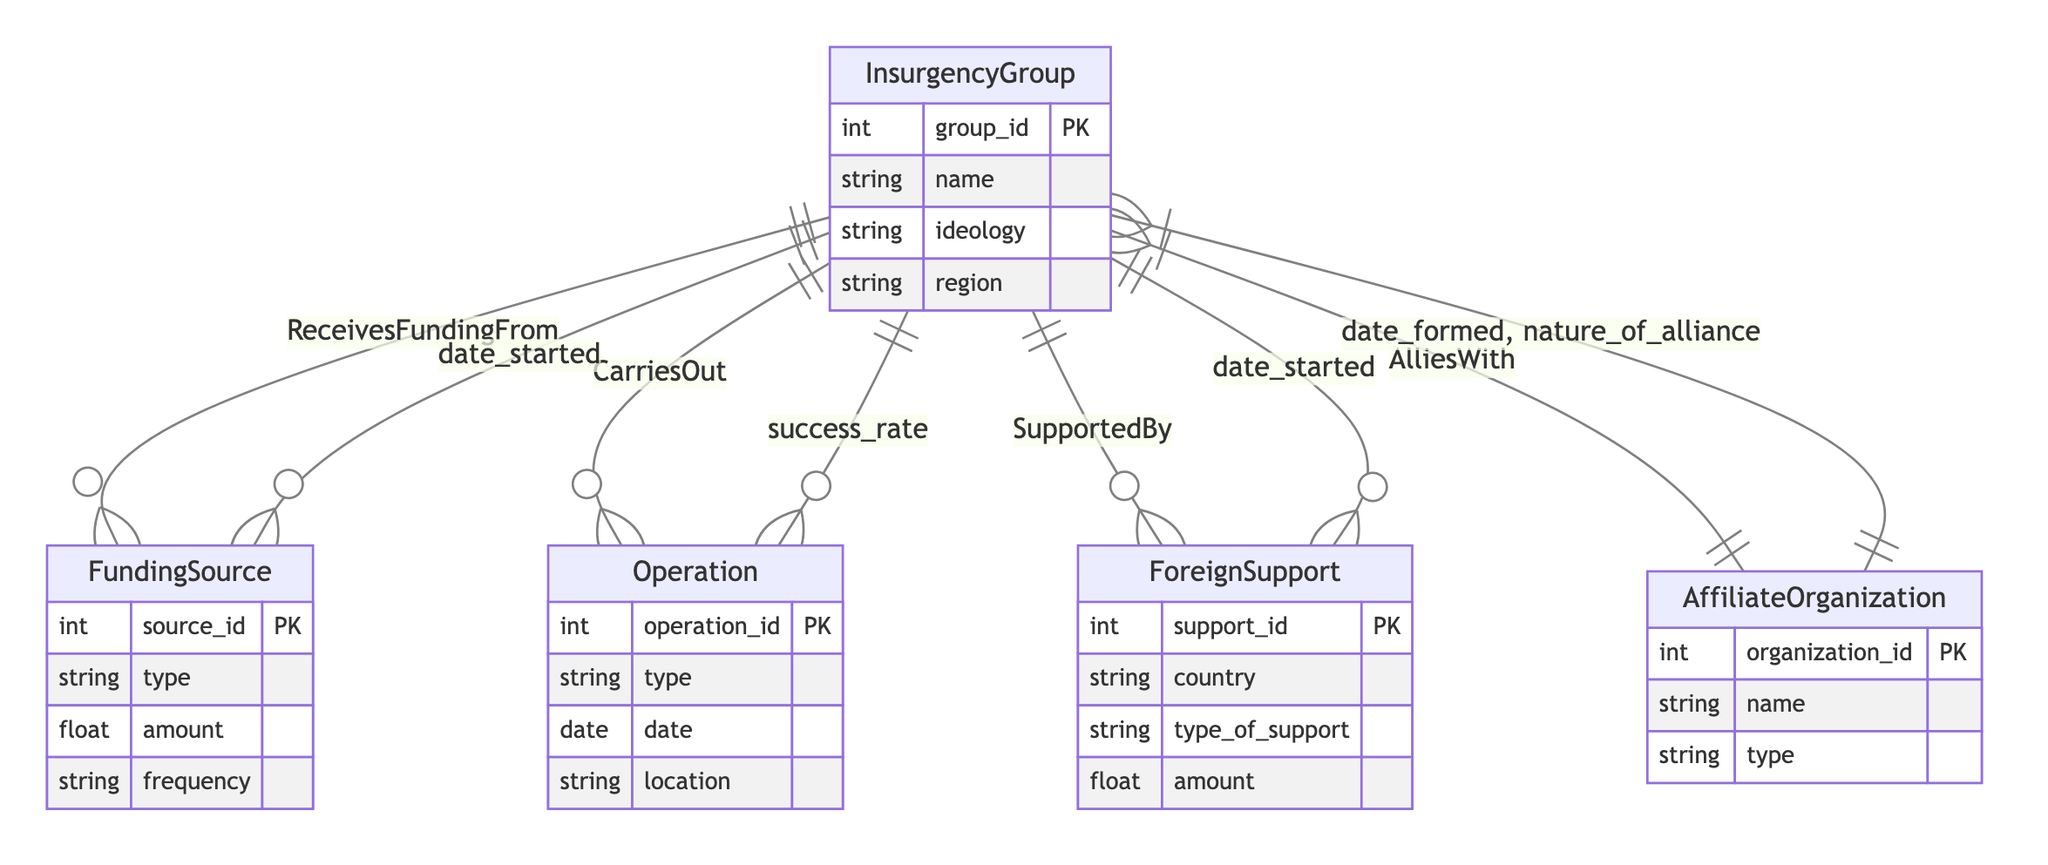What are the primary entities represented in the diagram? The entities in the diagram include InsurgencyGroup, FundingSource, Operation, ForeignSupport, and AffiliateOrganization. Each entity represents a distinct aspect of insurgency movements and their dynamics.
Answer: InsurgencyGroup, FundingSource, Operation, ForeignSupport, AffiliateOrganization How many relationships exist between the InsurgencyGroup and FundingSource? The diagram shows one relationship called "ReceivesFundingFrom" between InsurgencyGroup and FundingSource, which indicates that an insurgency group receives funding from one or more funding sources.
Answer: One What type of support can an InsurgencyGroup receive from ForeignSupport? The InsurgencyGroup can receive various types of support, including arms, training, and financial assistance, as specified in the attributes of the ForeignSupport entity.
Answer: Arms, training, financial What is the nature of the relationship between InsurgencyGroup and AffiliateOrganization? The relationship between InsurgencyGroup and AffiliateOrganization is many to many, indicating that an insurgency group can ally with multiple organizations, and vice versa.
Answer: Many to many Why would an InsurgencyGroup need to detail the success rate of its Operations? The success rate of operations is crucial for assessing the effectiveness and viability of the insurgency's tactics, and it helps inform strategy. This rate is represented as an attribute in the relationship "CarriesOut".
Answer: Strategy Which entity has a primary key attribute of "amount"? The entity FundingSource has a primary key attribute called "amount" that estimates the funding received, linking funding sources to specific insurgency groups.
Answer: FundingSource Are the characteristics of the FundingSource related to the InsurgencyGroup? Yes, through the relationship "ReceivesFundingFrom", characteristics such as the type and amount of funding directly relate to how insurgency groups sustain their operations.
Answer: Yes What aspect does the "date_formed" attribute represent in the relationship with AffiliateOrganization? The "date_formed" attribute specifies when an alliance between the InsurgencyGroup and the AffiliateOrganization was established, marking the beginning of their relationship.
Answer: Alliance establishment What does the "frequency" attribute in the FundingSource indicate? The "frequency" attribute represents how often the funding is received by the insurgency group, determining its financial flow and reliability in sustaining operations.
Answer: Funding frequency 